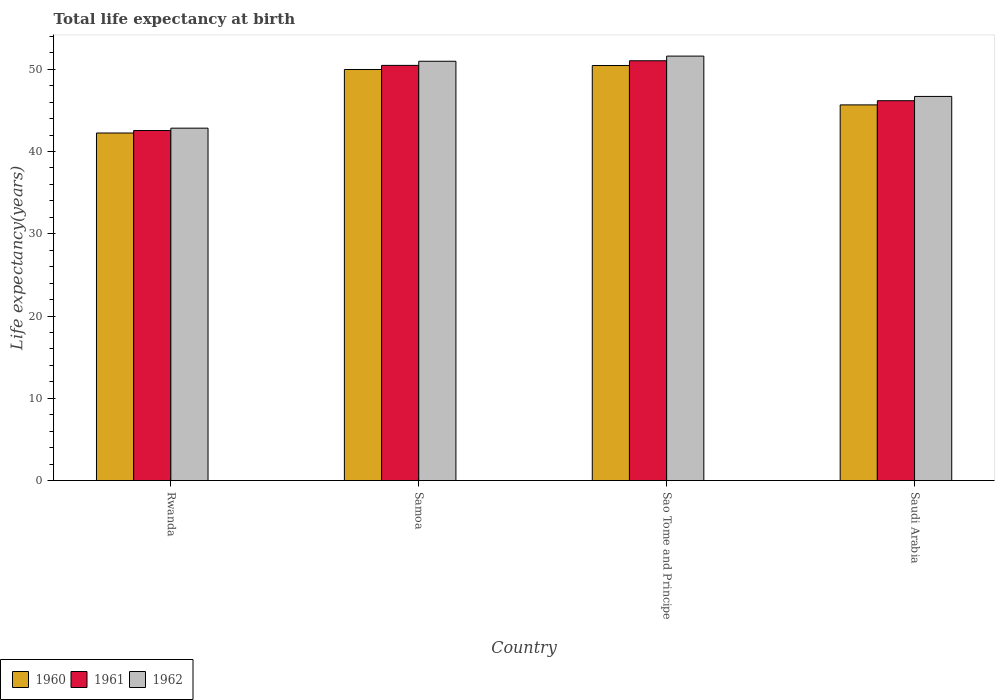How many different coloured bars are there?
Provide a succinct answer. 3. How many bars are there on the 2nd tick from the right?
Your response must be concise. 3. What is the label of the 4th group of bars from the left?
Keep it short and to the point. Saudi Arabia. In how many cases, is the number of bars for a given country not equal to the number of legend labels?
Ensure brevity in your answer.  0. What is the life expectancy at birth in in 1962 in Samoa?
Your response must be concise. 50.97. Across all countries, what is the maximum life expectancy at birth in in 1962?
Keep it short and to the point. 51.6. Across all countries, what is the minimum life expectancy at birth in in 1960?
Offer a terse response. 42.25. In which country was the life expectancy at birth in in 1962 maximum?
Your response must be concise. Sao Tome and Principe. In which country was the life expectancy at birth in in 1960 minimum?
Offer a very short reply. Rwanda. What is the total life expectancy at birth in in 1961 in the graph?
Your answer should be compact. 190.22. What is the difference between the life expectancy at birth in in 1961 in Sao Tome and Principe and that in Saudi Arabia?
Ensure brevity in your answer.  4.86. What is the difference between the life expectancy at birth in in 1961 in Rwanda and the life expectancy at birth in in 1962 in Samoa?
Your answer should be compact. -8.42. What is the average life expectancy at birth in in 1962 per country?
Your response must be concise. 48.02. In how many countries, is the life expectancy at birth in in 1961 greater than 52 years?
Your answer should be very brief. 0. What is the ratio of the life expectancy at birth in in 1960 in Samoa to that in Saudi Arabia?
Ensure brevity in your answer.  1.09. Is the life expectancy at birth in in 1962 in Rwanda less than that in Samoa?
Ensure brevity in your answer.  Yes. Is the difference between the life expectancy at birth in in 1961 in Rwanda and Sao Tome and Principe greater than the difference between the life expectancy at birth in in 1960 in Rwanda and Sao Tome and Principe?
Your response must be concise. No. What is the difference between the highest and the second highest life expectancy at birth in in 1960?
Give a very brief answer. -0.48. What is the difference between the highest and the lowest life expectancy at birth in in 1962?
Offer a terse response. 8.76. What does the 2nd bar from the left in Rwanda represents?
Provide a short and direct response. 1961. What does the 2nd bar from the right in Sao Tome and Principe represents?
Your answer should be compact. 1961. Are all the bars in the graph horizontal?
Your answer should be compact. No. What is the difference between two consecutive major ticks on the Y-axis?
Your response must be concise. 10. Are the values on the major ticks of Y-axis written in scientific E-notation?
Provide a succinct answer. No. Does the graph contain any zero values?
Your response must be concise. No. Does the graph contain grids?
Offer a very short reply. No. What is the title of the graph?
Offer a terse response. Total life expectancy at birth. What is the label or title of the Y-axis?
Your response must be concise. Life expectancy(years). What is the Life expectancy(years) in 1960 in Rwanda?
Your response must be concise. 42.25. What is the Life expectancy(years) in 1961 in Rwanda?
Your response must be concise. 42.55. What is the Life expectancy(years) in 1962 in Rwanda?
Keep it short and to the point. 42.84. What is the Life expectancy(years) in 1960 in Samoa?
Provide a short and direct response. 49.97. What is the Life expectancy(years) in 1961 in Samoa?
Your response must be concise. 50.47. What is the Life expectancy(years) of 1962 in Samoa?
Your response must be concise. 50.97. What is the Life expectancy(years) of 1960 in Sao Tome and Principe?
Provide a short and direct response. 50.45. What is the Life expectancy(years) in 1961 in Sao Tome and Principe?
Provide a succinct answer. 51.03. What is the Life expectancy(years) of 1962 in Sao Tome and Principe?
Provide a succinct answer. 51.6. What is the Life expectancy(years) in 1960 in Saudi Arabia?
Give a very brief answer. 45.67. What is the Life expectancy(years) of 1961 in Saudi Arabia?
Your answer should be compact. 46.17. What is the Life expectancy(years) of 1962 in Saudi Arabia?
Your response must be concise. 46.69. Across all countries, what is the maximum Life expectancy(years) of 1960?
Your answer should be very brief. 50.45. Across all countries, what is the maximum Life expectancy(years) in 1961?
Ensure brevity in your answer.  51.03. Across all countries, what is the maximum Life expectancy(years) in 1962?
Your answer should be very brief. 51.6. Across all countries, what is the minimum Life expectancy(years) in 1960?
Your response must be concise. 42.25. Across all countries, what is the minimum Life expectancy(years) in 1961?
Make the answer very short. 42.55. Across all countries, what is the minimum Life expectancy(years) of 1962?
Keep it short and to the point. 42.84. What is the total Life expectancy(years) in 1960 in the graph?
Provide a short and direct response. 188.34. What is the total Life expectancy(years) in 1961 in the graph?
Provide a succinct answer. 190.22. What is the total Life expectancy(years) of 1962 in the graph?
Provide a short and direct response. 192.1. What is the difference between the Life expectancy(years) in 1960 in Rwanda and that in Samoa?
Offer a terse response. -7.72. What is the difference between the Life expectancy(years) of 1961 in Rwanda and that in Samoa?
Provide a succinct answer. -7.92. What is the difference between the Life expectancy(years) in 1962 in Rwanda and that in Samoa?
Offer a very short reply. -8.13. What is the difference between the Life expectancy(years) in 1960 in Rwanda and that in Sao Tome and Principe?
Provide a succinct answer. -8.2. What is the difference between the Life expectancy(years) of 1961 in Rwanda and that in Sao Tome and Principe?
Provide a short and direct response. -8.48. What is the difference between the Life expectancy(years) of 1962 in Rwanda and that in Sao Tome and Principe?
Provide a succinct answer. -8.76. What is the difference between the Life expectancy(years) in 1960 in Rwanda and that in Saudi Arabia?
Provide a succinct answer. -3.42. What is the difference between the Life expectancy(years) of 1961 in Rwanda and that in Saudi Arabia?
Provide a succinct answer. -3.63. What is the difference between the Life expectancy(years) of 1962 in Rwanda and that in Saudi Arabia?
Give a very brief answer. -3.86. What is the difference between the Life expectancy(years) of 1960 in Samoa and that in Sao Tome and Principe?
Offer a very short reply. -0.48. What is the difference between the Life expectancy(years) of 1961 in Samoa and that in Sao Tome and Principe?
Provide a succinct answer. -0.56. What is the difference between the Life expectancy(years) in 1962 in Samoa and that in Sao Tome and Principe?
Provide a succinct answer. -0.63. What is the difference between the Life expectancy(years) in 1960 in Samoa and that in Saudi Arabia?
Keep it short and to the point. 4.3. What is the difference between the Life expectancy(years) of 1961 in Samoa and that in Saudi Arabia?
Provide a short and direct response. 4.3. What is the difference between the Life expectancy(years) in 1962 in Samoa and that in Saudi Arabia?
Your response must be concise. 4.28. What is the difference between the Life expectancy(years) of 1960 in Sao Tome and Principe and that in Saudi Arabia?
Ensure brevity in your answer.  4.79. What is the difference between the Life expectancy(years) of 1961 in Sao Tome and Principe and that in Saudi Arabia?
Make the answer very short. 4.86. What is the difference between the Life expectancy(years) in 1962 in Sao Tome and Principe and that in Saudi Arabia?
Your answer should be very brief. 4.9. What is the difference between the Life expectancy(years) in 1960 in Rwanda and the Life expectancy(years) in 1961 in Samoa?
Provide a succinct answer. -8.22. What is the difference between the Life expectancy(years) of 1960 in Rwanda and the Life expectancy(years) of 1962 in Samoa?
Your response must be concise. -8.72. What is the difference between the Life expectancy(years) of 1961 in Rwanda and the Life expectancy(years) of 1962 in Samoa?
Your answer should be compact. -8.42. What is the difference between the Life expectancy(years) in 1960 in Rwanda and the Life expectancy(years) in 1961 in Sao Tome and Principe?
Provide a short and direct response. -8.78. What is the difference between the Life expectancy(years) of 1960 in Rwanda and the Life expectancy(years) of 1962 in Sao Tome and Principe?
Your answer should be very brief. -9.35. What is the difference between the Life expectancy(years) of 1961 in Rwanda and the Life expectancy(years) of 1962 in Sao Tome and Principe?
Ensure brevity in your answer.  -9.05. What is the difference between the Life expectancy(years) in 1960 in Rwanda and the Life expectancy(years) in 1961 in Saudi Arabia?
Your response must be concise. -3.93. What is the difference between the Life expectancy(years) in 1960 in Rwanda and the Life expectancy(years) in 1962 in Saudi Arabia?
Give a very brief answer. -4.45. What is the difference between the Life expectancy(years) of 1961 in Rwanda and the Life expectancy(years) of 1962 in Saudi Arabia?
Provide a succinct answer. -4.15. What is the difference between the Life expectancy(years) in 1960 in Samoa and the Life expectancy(years) in 1961 in Sao Tome and Principe?
Ensure brevity in your answer.  -1.06. What is the difference between the Life expectancy(years) of 1960 in Samoa and the Life expectancy(years) of 1962 in Sao Tome and Principe?
Make the answer very short. -1.63. What is the difference between the Life expectancy(years) in 1961 in Samoa and the Life expectancy(years) in 1962 in Sao Tome and Principe?
Provide a short and direct response. -1.13. What is the difference between the Life expectancy(years) in 1960 in Samoa and the Life expectancy(years) in 1961 in Saudi Arabia?
Your answer should be very brief. 3.8. What is the difference between the Life expectancy(years) of 1960 in Samoa and the Life expectancy(years) of 1962 in Saudi Arabia?
Offer a very short reply. 3.27. What is the difference between the Life expectancy(years) of 1961 in Samoa and the Life expectancy(years) of 1962 in Saudi Arabia?
Keep it short and to the point. 3.77. What is the difference between the Life expectancy(years) of 1960 in Sao Tome and Principe and the Life expectancy(years) of 1961 in Saudi Arabia?
Keep it short and to the point. 4.28. What is the difference between the Life expectancy(years) of 1960 in Sao Tome and Principe and the Life expectancy(years) of 1962 in Saudi Arabia?
Make the answer very short. 3.76. What is the difference between the Life expectancy(years) in 1961 in Sao Tome and Principe and the Life expectancy(years) in 1962 in Saudi Arabia?
Your answer should be compact. 4.34. What is the average Life expectancy(years) of 1960 per country?
Offer a terse response. 47.08. What is the average Life expectancy(years) in 1961 per country?
Your answer should be very brief. 47.56. What is the average Life expectancy(years) of 1962 per country?
Offer a very short reply. 48.02. What is the difference between the Life expectancy(years) of 1960 and Life expectancy(years) of 1961 in Rwanda?
Offer a very short reply. -0.3. What is the difference between the Life expectancy(years) of 1960 and Life expectancy(years) of 1962 in Rwanda?
Your answer should be very brief. -0.59. What is the difference between the Life expectancy(years) in 1961 and Life expectancy(years) in 1962 in Rwanda?
Give a very brief answer. -0.29. What is the difference between the Life expectancy(years) of 1960 and Life expectancy(years) of 1962 in Samoa?
Provide a succinct answer. -1. What is the difference between the Life expectancy(years) in 1961 and Life expectancy(years) in 1962 in Samoa?
Offer a very short reply. -0.5. What is the difference between the Life expectancy(years) of 1960 and Life expectancy(years) of 1961 in Sao Tome and Principe?
Provide a succinct answer. -0.58. What is the difference between the Life expectancy(years) of 1960 and Life expectancy(years) of 1962 in Sao Tome and Principe?
Keep it short and to the point. -1.15. What is the difference between the Life expectancy(years) in 1961 and Life expectancy(years) in 1962 in Sao Tome and Principe?
Make the answer very short. -0.57. What is the difference between the Life expectancy(years) of 1960 and Life expectancy(years) of 1961 in Saudi Arabia?
Offer a very short reply. -0.51. What is the difference between the Life expectancy(years) of 1960 and Life expectancy(years) of 1962 in Saudi Arabia?
Your answer should be compact. -1.03. What is the difference between the Life expectancy(years) in 1961 and Life expectancy(years) in 1962 in Saudi Arabia?
Ensure brevity in your answer.  -0.52. What is the ratio of the Life expectancy(years) of 1960 in Rwanda to that in Samoa?
Give a very brief answer. 0.85. What is the ratio of the Life expectancy(years) of 1961 in Rwanda to that in Samoa?
Provide a succinct answer. 0.84. What is the ratio of the Life expectancy(years) of 1962 in Rwanda to that in Samoa?
Your response must be concise. 0.84. What is the ratio of the Life expectancy(years) in 1960 in Rwanda to that in Sao Tome and Principe?
Keep it short and to the point. 0.84. What is the ratio of the Life expectancy(years) in 1961 in Rwanda to that in Sao Tome and Principe?
Your response must be concise. 0.83. What is the ratio of the Life expectancy(years) of 1962 in Rwanda to that in Sao Tome and Principe?
Your answer should be very brief. 0.83. What is the ratio of the Life expectancy(years) of 1960 in Rwanda to that in Saudi Arabia?
Keep it short and to the point. 0.93. What is the ratio of the Life expectancy(years) of 1961 in Rwanda to that in Saudi Arabia?
Ensure brevity in your answer.  0.92. What is the ratio of the Life expectancy(years) of 1962 in Rwanda to that in Saudi Arabia?
Your answer should be compact. 0.92. What is the ratio of the Life expectancy(years) of 1960 in Samoa to that in Saudi Arabia?
Your answer should be very brief. 1.09. What is the ratio of the Life expectancy(years) in 1961 in Samoa to that in Saudi Arabia?
Your answer should be very brief. 1.09. What is the ratio of the Life expectancy(years) of 1962 in Samoa to that in Saudi Arabia?
Keep it short and to the point. 1.09. What is the ratio of the Life expectancy(years) of 1960 in Sao Tome and Principe to that in Saudi Arabia?
Offer a very short reply. 1.1. What is the ratio of the Life expectancy(years) in 1961 in Sao Tome and Principe to that in Saudi Arabia?
Keep it short and to the point. 1.11. What is the ratio of the Life expectancy(years) in 1962 in Sao Tome and Principe to that in Saudi Arabia?
Make the answer very short. 1.1. What is the difference between the highest and the second highest Life expectancy(years) in 1960?
Offer a terse response. 0.48. What is the difference between the highest and the second highest Life expectancy(years) of 1961?
Provide a succinct answer. 0.56. What is the difference between the highest and the second highest Life expectancy(years) of 1962?
Provide a succinct answer. 0.63. What is the difference between the highest and the lowest Life expectancy(years) of 1960?
Provide a succinct answer. 8.2. What is the difference between the highest and the lowest Life expectancy(years) in 1961?
Your response must be concise. 8.48. What is the difference between the highest and the lowest Life expectancy(years) of 1962?
Provide a short and direct response. 8.76. 